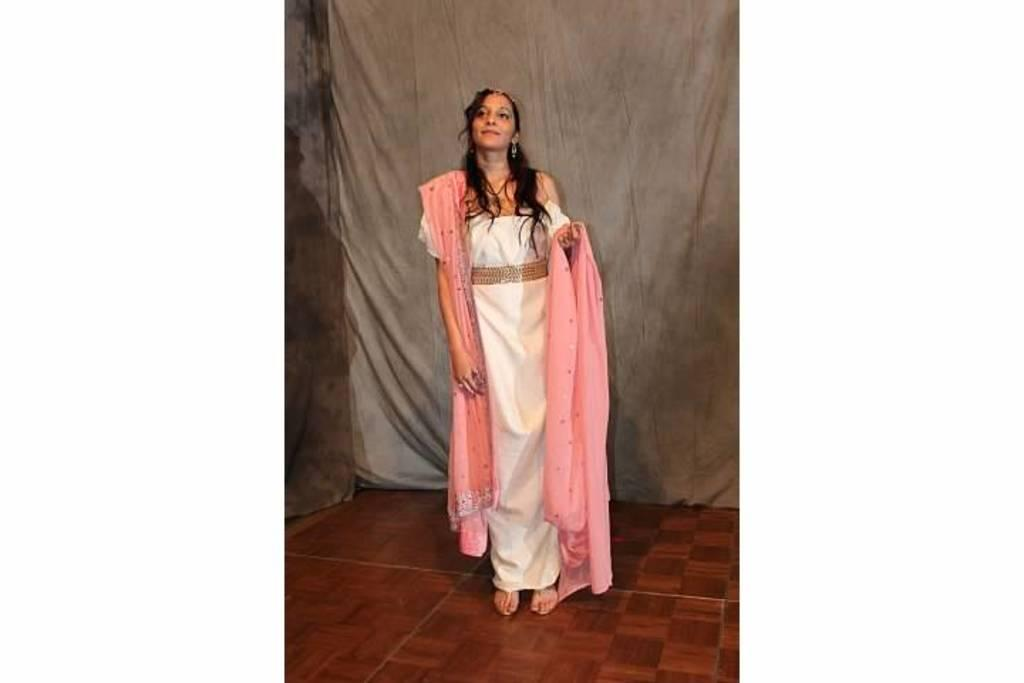What is the main subject of the image? There is a person standing in the image. What can be seen beneath the person's feet? The ground is visible in the image. What type of material is visible in the background? There is cloth visible in the background of the image. What type of engine can be seen powering the train in the image? There is no train or engine present in the image; it features a person standing on the ground with cloth visible in the background. What is the color of the tongue sticking out of the person's mouth in the image? There is no tongue visible in the image; it only shows a person standing on the ground with cloth visible in the background. 